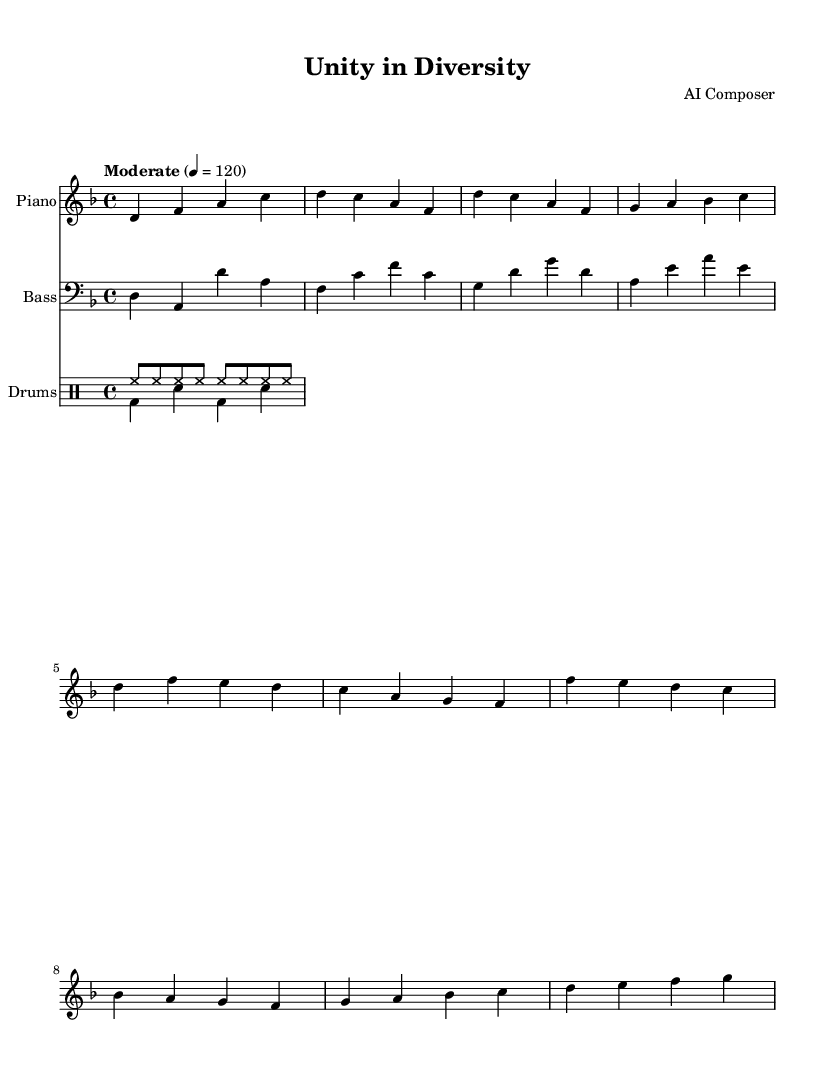What is the key signature of this music? The key signature is D minor, which has one flat (the note C). It can be identified by looking at the key signature section at the beginning of the staff.
Answer: D minor What is the time signature of this music? The time signature is 4/4, indicated by the fraction shown at the beginning of the score. This means there are four beats in each measure.
Answer: 4/4 What tempo marking is provided for the piece? The tempo marking indicates "Moderate" at a speed of 120 beats per minute, specified directly above the staff.
Answer: Moderate How many measures are in the piano part? By counting the distinct groups of notes divided by vertical lines, we can determine that there are 8 measures in the piano part.
Answer: 8 What is the primary chord structure in the first four measures of the piano part? The first four measures primarily outline d minor and its related triads, which can be determined by analyzing the notes played in those measures: D, F, A, and C.
Answer: D minor Which instrument plays the bass part? The bass part is written for the bass clef, indicated at the beginning of that staff, which shows it is played by a bass instrument.
Answer: Bass What rhythmic pattern is used in the drum section? The drum section uses alternating eighth notes for the hi-hat and a simple kick-snare pattern, which can be deciphered by examining the symbols used in the drum staff.
Answer: Hi-hat and kick-snare 